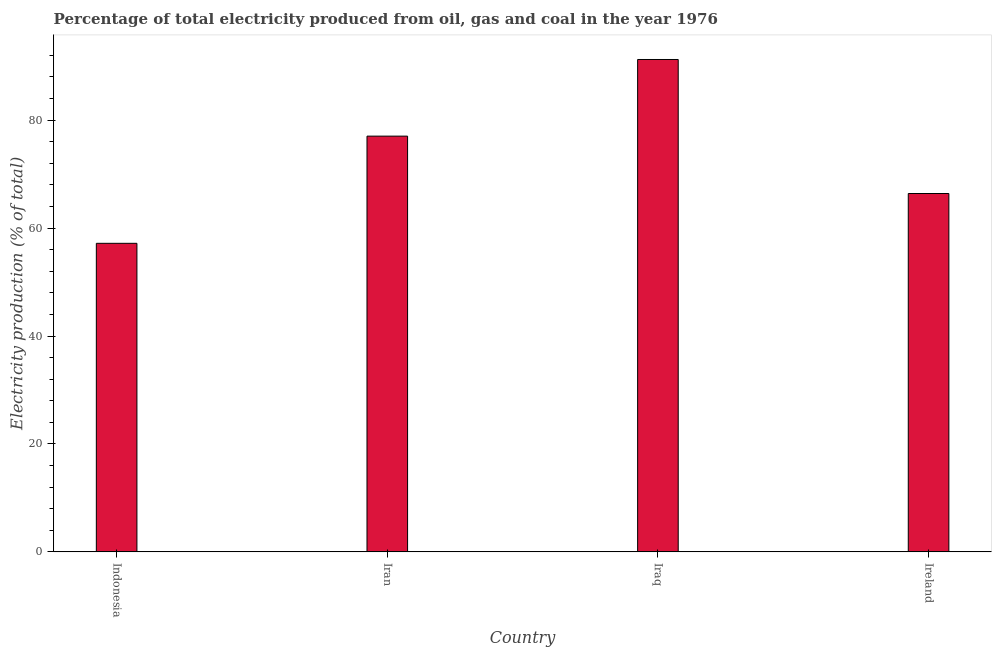Does the graph contain any zero values?
Your answer should be very brief. No. What is the title of the graph?
Your response must be concise. Percentage of total electricity produced from oil, gas and coal in the year 1976. What is the label or title of the Y-axis?
Your response must be concise. Electricity production (% of total). What is the electricity production in Indonesia?
Provide a succinct answer. 57.18. Across all countries, what is the maximum electricity production?
Provide a short and direct response. 91.24. Across all countries, what is the minimum electricity production?
Your response must be concise. 57.18. In which country was the electricity production maximum?
Your response must be concise. Iraq. What is the sum of the electricity production?
Your answer should be compact. 291.86. What is the difference between the electricity production in Iran and Iraq?
Keep it short and to the point. -14.2. What is the average electricity production per country?
Give a very brief answer. 72.97. What is the median electricity production?
Ensure brevity in your answer.  71.72. In how many countries, is the electricity production greater than 84 %?
Your answer should be very brief. 1. What is the ratio of the electricity production in Iran to that in Ireland?
Your response must be concise. 1.16. Is the electricity production in Indonesia less than that in Iran?
Your answer should be compact. Yes. Is the difference between the electricity production in Indonesia and Iran greater than the difference between any two countries?
Offer a terse response. No. What is the difference between the highest and the second highest electricity production?
Ensure brevity in your answer.  14.2. What is the difference between the highest and the lowest electricity production?
Give a very brief answer. 34.06. How many bars are there?
Offer a terse response. 4. Are all the bars in the graph horizontal?
Your response must be concise. No. What is the difference between two consecutive major ticks on the Y-axis?
Offer a terse response. 20. What is the Electricity production (% of total) of Indonesia?
Provide a short and direct response. 57.18. What is the Electricity production (% of total) of Iran?
Keep it short and to the point. 77.04. What is the Electricity production (% of total) in Iraq?
Provide a short and direct response. 91.24. What is the Electricity production (% of total) in Ireland?
Make the answer very short. 66.41. What is the difference between the Electricity production (% of total) in Indonesia and Iran?
Give a very brief answer. -19.86. What is the difference between the Electricity production (% of total) in Indonesia and Iraq?
Make the answer very short. -34.06. What is the difference between the Electricity production (% of total) in Indonesia and Ireland?
Provide a short and direct response. -9.23. What is the difference between the Electricity production (% of total) in Iran and Iraq?
Ensure brevity in your answer.  -14.2. What is the difference between the Electricity production (% of total) in Iran and Ireland?
Your answer should be compact. 10.63. What is the difference between the Electricity production (% of total) in Iraq and Ireland?
Offer a very short reply. 24.83. What is the ratio of the Electricity production (% of total) in Indonesia to that in Iran?
Offer a very short reply. 0.74. What is the ratio of the Electricity production (% of total) in Indonesia to that in Iraq?
Provide a short and direct response. 0.63. What is the ratio of the Electricity production (% of total) in Indonesia to that in Ireland?
Ensure brevity in your answer.  0.86. What is the ratio of the Electricity production (% of total) in Iran to that in Iraq?
Keep it short and to the point. 0.84. What is the ratio of the Electricity production (% of total) in Iran to that in Ireland?
Give a very brief answer. 1.16. What is the ratio of the Electricity production (% of total) in Iraq to that in Ireland?
Ensure brevity in your answer.  1.37. 